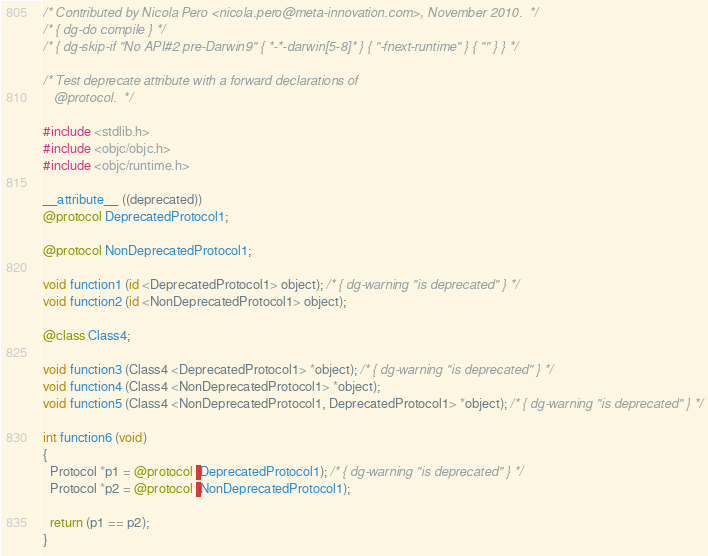<code> <loc_0><loc_0><loc_500><loc_500><_ObjectiveC_>/* Contributed by Nicola Pero <nicola.pero@meta-innovation.com>, November 2010.  */
/* { dg-do compile } */
/* { dg-skip-if "No API#2 pre-Darwin9" { *-*-darwin[5-8]* } { "-fnext-runtime" } { "" } } */

/* Test deprecate attribute with a forward declarations of
   @protocol.  */

#include <stdlib.h>
#include <objc/objc.h>
#include <objc/runtime.h>

__attribute__ ((deprecated))
@protocol DeprecatedProtocol1;

@protocol NonDeprecatedProtocol1;

void function1 (id <DeprecatedProtocol1> object); /* { dg-warning "is deprecated" } */
void function2 (id <NonDeprecatedProtocol1> object);

@class Class4;

void function3 (Class4 <DeprecatedProtocol1> *object); /* { dg-warning "is deprecated" } */
void function4 (Class4 <NonDeprecatedProtocol1> *object);
void function5 (Class4 <NonDeprecatedProtocol1, DeprecatedProtocol1> *object); /* { dg-warning "is deprecated" } */

int function6 (void)
{
  Protocol *p1 = @protocol (DeprecatedProtocol1); /* { dg-warning "is deprecated" } */
  Protocol *p2 = @protocol (NonDeprecatedProtocol1);

  return (p1 == p2);
}

</code> 